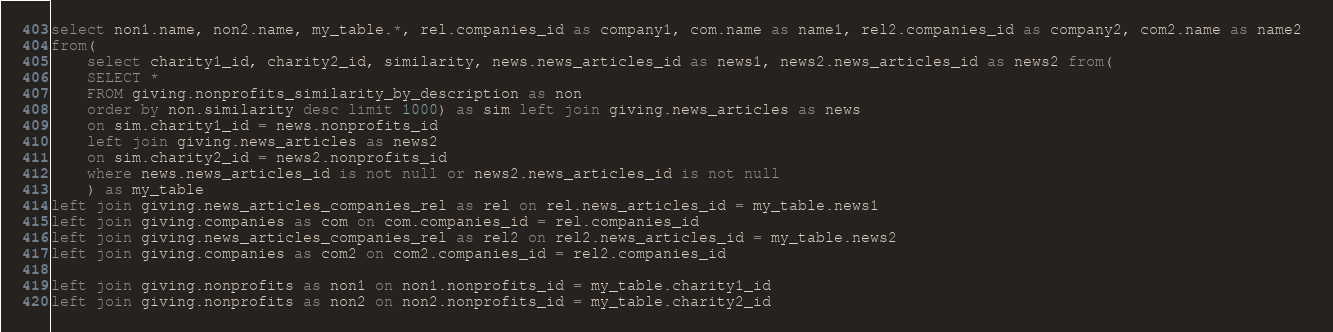Convert code to text. <code><loc_0><loc_0><loc_500><loc_500><_SQL_>select non1.name, non2.name, my_table.*, rel.companies_id as company1, com.name as name1, rel2.companies_id as company2, com2.name as name2 
from(
	select charity1_id, charity2_id, similarity, news.news_articles_id as news1, news2.news_articles_id as news2 from(
	SELECT * 
	FROM giving.nonprofits_similarity_by_description as non
	order by non.similarity desc limit 1000) as sim left join giving.news_articles as news
	on sim.charity1_id = news.nonprofits_id
	left join giving.news_articles as news2
	on sim.charity2_id = news2.nonprofits_id
	where news.news_articles_id is not null or news2.news_articles_id is not null
	) as my_table
left join giving.news_articles_companies_rel as rel on rel.news_articles_id = my_table.news1
left join giving.companies as com on com.companies_id = rel.companies_id
left join giving.news_articles_companies_rel as rel2 on rel2.news_articles_id = my_table.news2
left join giving.companies as com2 on com2.companies_id = rel2.companies_id

left join giving.nonprofits as non1 on non1.nonprofits_id = my_table.charity1_id
left join giving.nonprofits as non2 on non2.nonprofits_id = my_table.charity2_id
</code> 